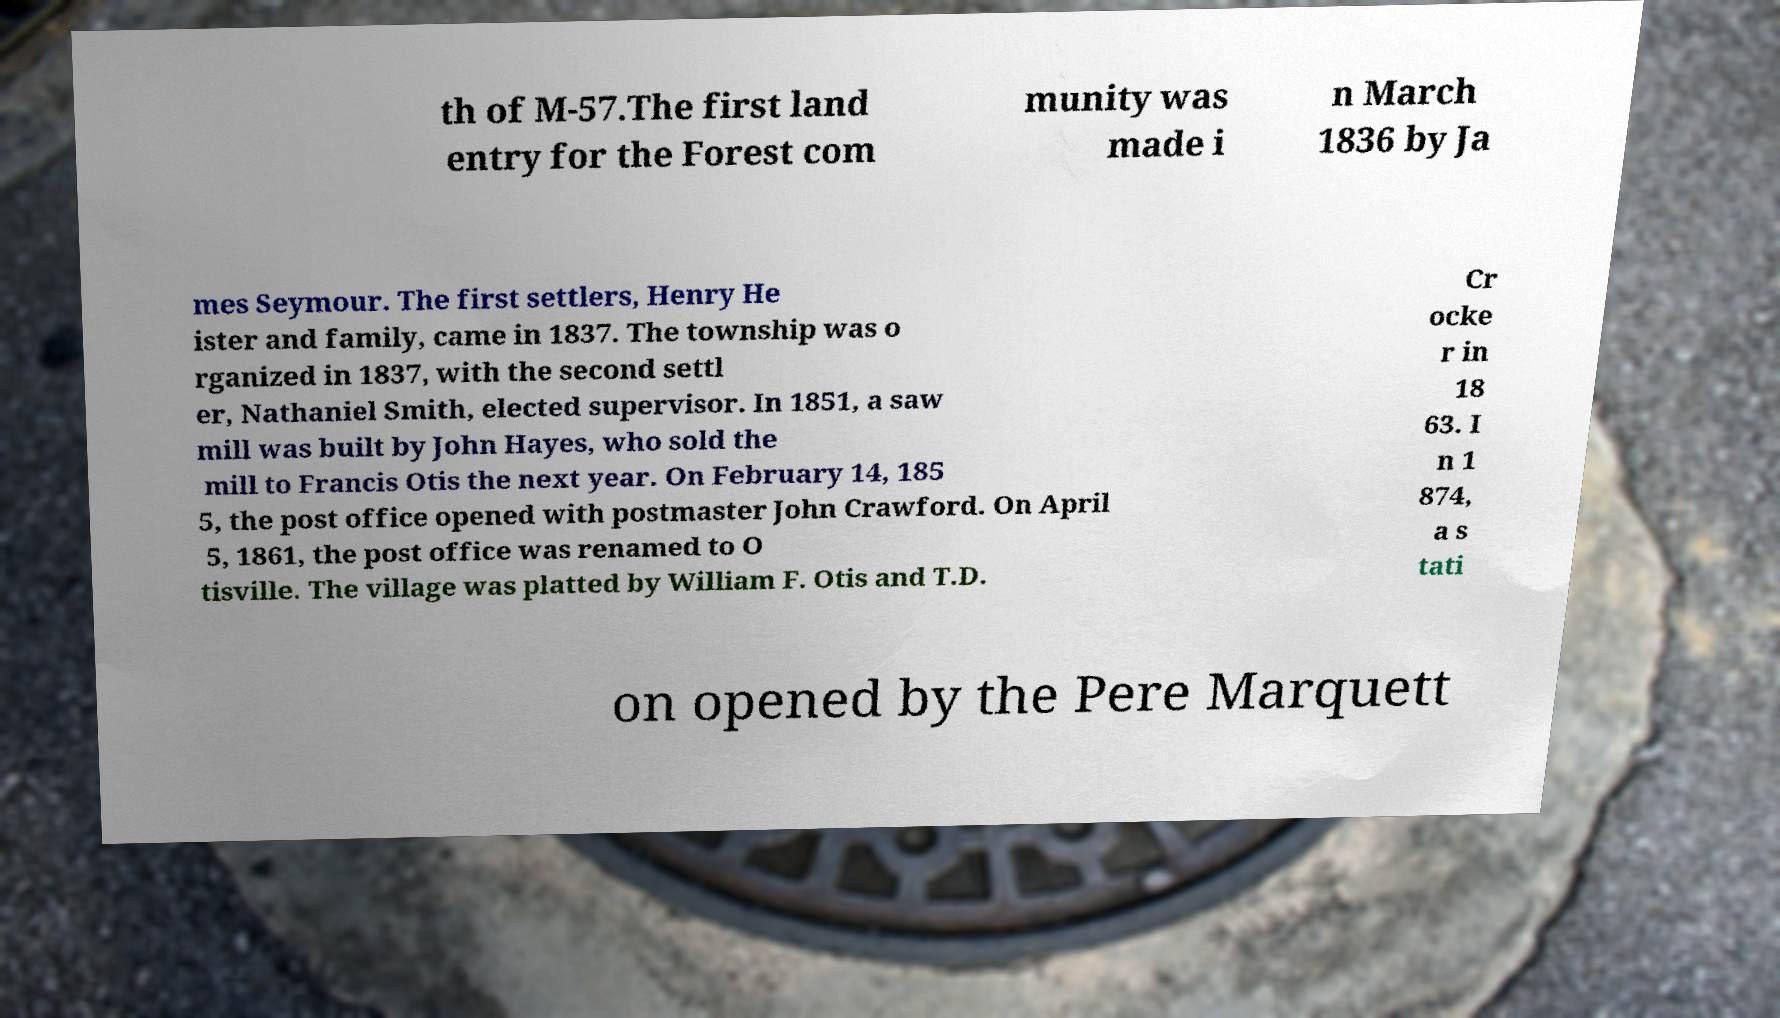Could you extract and type out the text from this image? th of M-57.The first land entry for the Forest com munity was made i n March 1836 by Ja mes Seymour. The first settlers, Henry He ister and family, came in 1837. The township was o rganized in 1837, with the second settl er, Nathaniel Smith, elected supervisor. In 1851, a saw mill was built by John Hayes, who sold the mill to Francis Otis the next year. On February 14, 185 5, the post office opened with postmaster John Crawford. On April 5, 1861, the post office was renamed to O tisville. The village was platted by William F. Otis and T.D. Cr ocke r in 18 63. I n 1 874, a s tati on opened by the Pere Marquett 